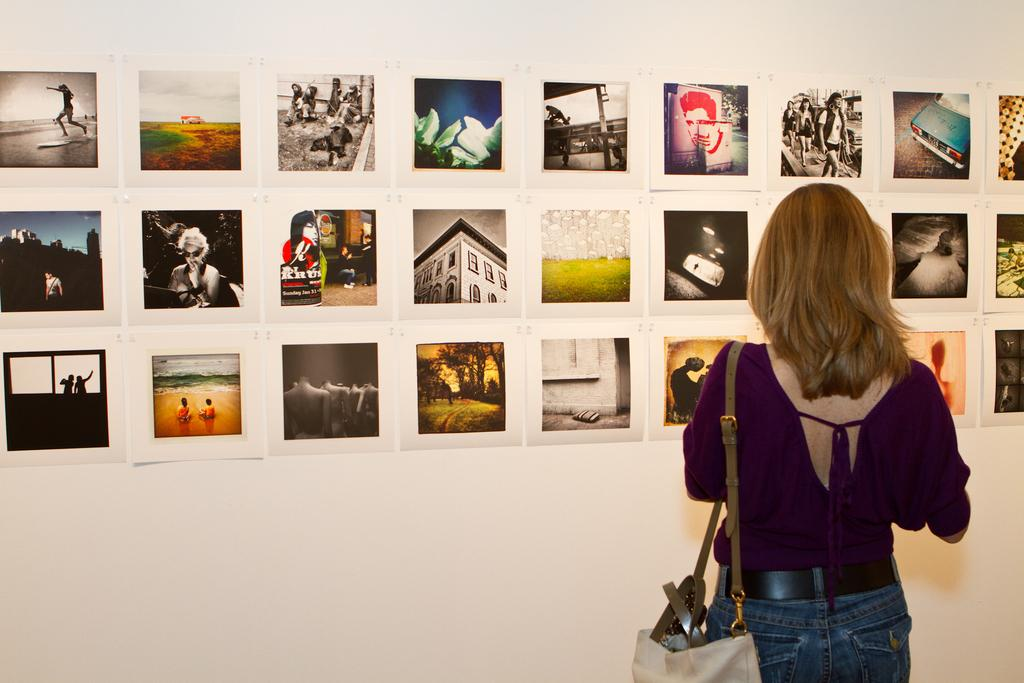Who is present in the image? There is a woman in the image. What is the woman doing in the image? The woman is standing on the floor. What is the woman wearing in the image? The woman is wearing a bag. What can be seen in the background of the image? There are wall paintings in the background of the image. Where might the image have been taken? The image may have been taken in a hall. What type of squirrel can be seen coughing in the image? There is no squirrel present in the image, nor is there any coughing. 